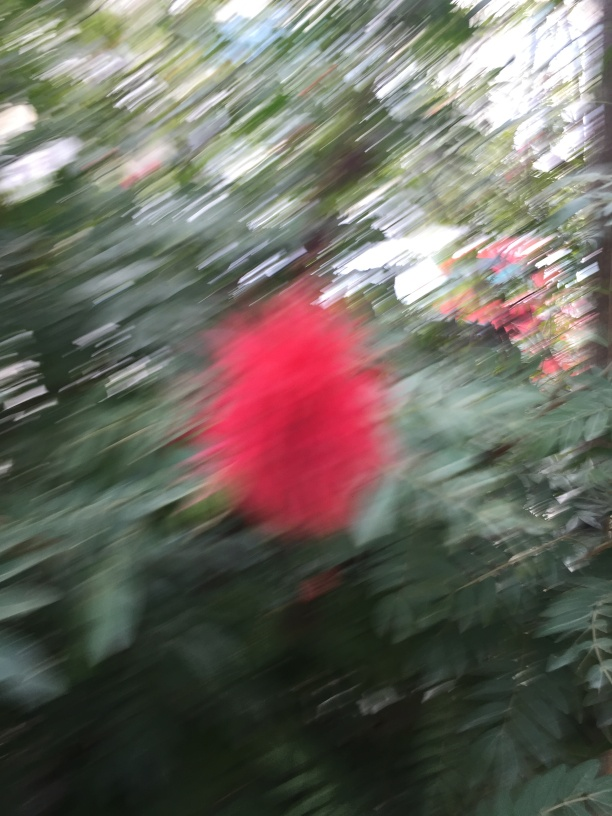What would be the best way to capture a clearer image in this situation? To ensure a clearer image, it's best to hold the camera steady or use a tripod to prevent motion blur. Employing a faster shutter speed can also help freeze the motion, and making sure the camera is focused on the intended subject will improve sharpness and detail. 